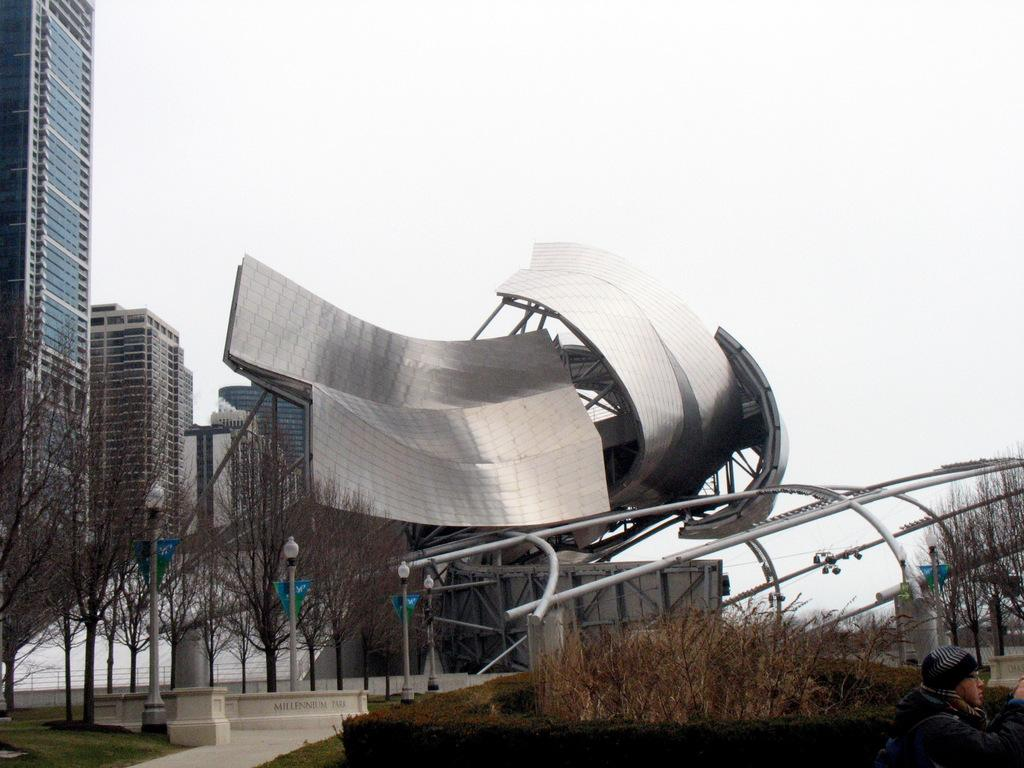What type of structures can be seen in the image? There are buildings in the image. What natural elements are present in the image? There are trees in the image. What type of man-made objects can be seen in the image? There are light poles and metal rods in the image. Is there a person in the image? Yes, there is a person in the image. What can be seen in the background of the image? The sky is visible in the background of the image. What type of wine is the person holding in the image? There is no wine present in the image; the person is not holding any wine. How many eyes does the tree have in the image? Trees do not have eyes, so this question cannot be answered. 